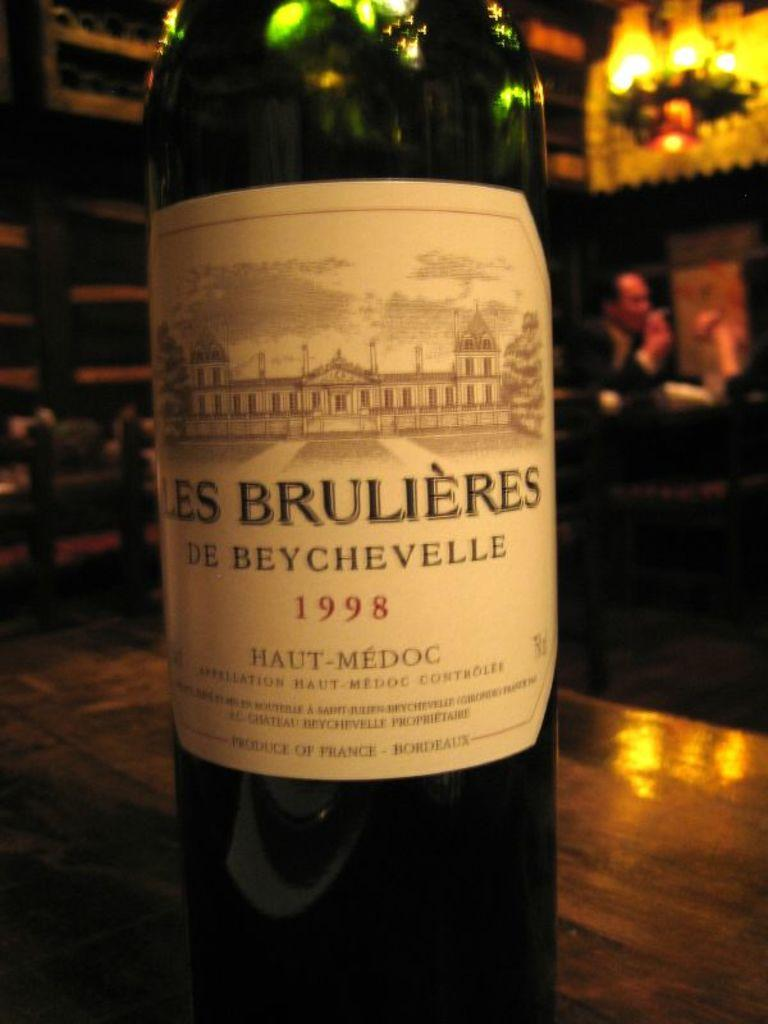<image>
Present a compact description of the photo's key features. The bottle of wine on the table is from the year 1998. 